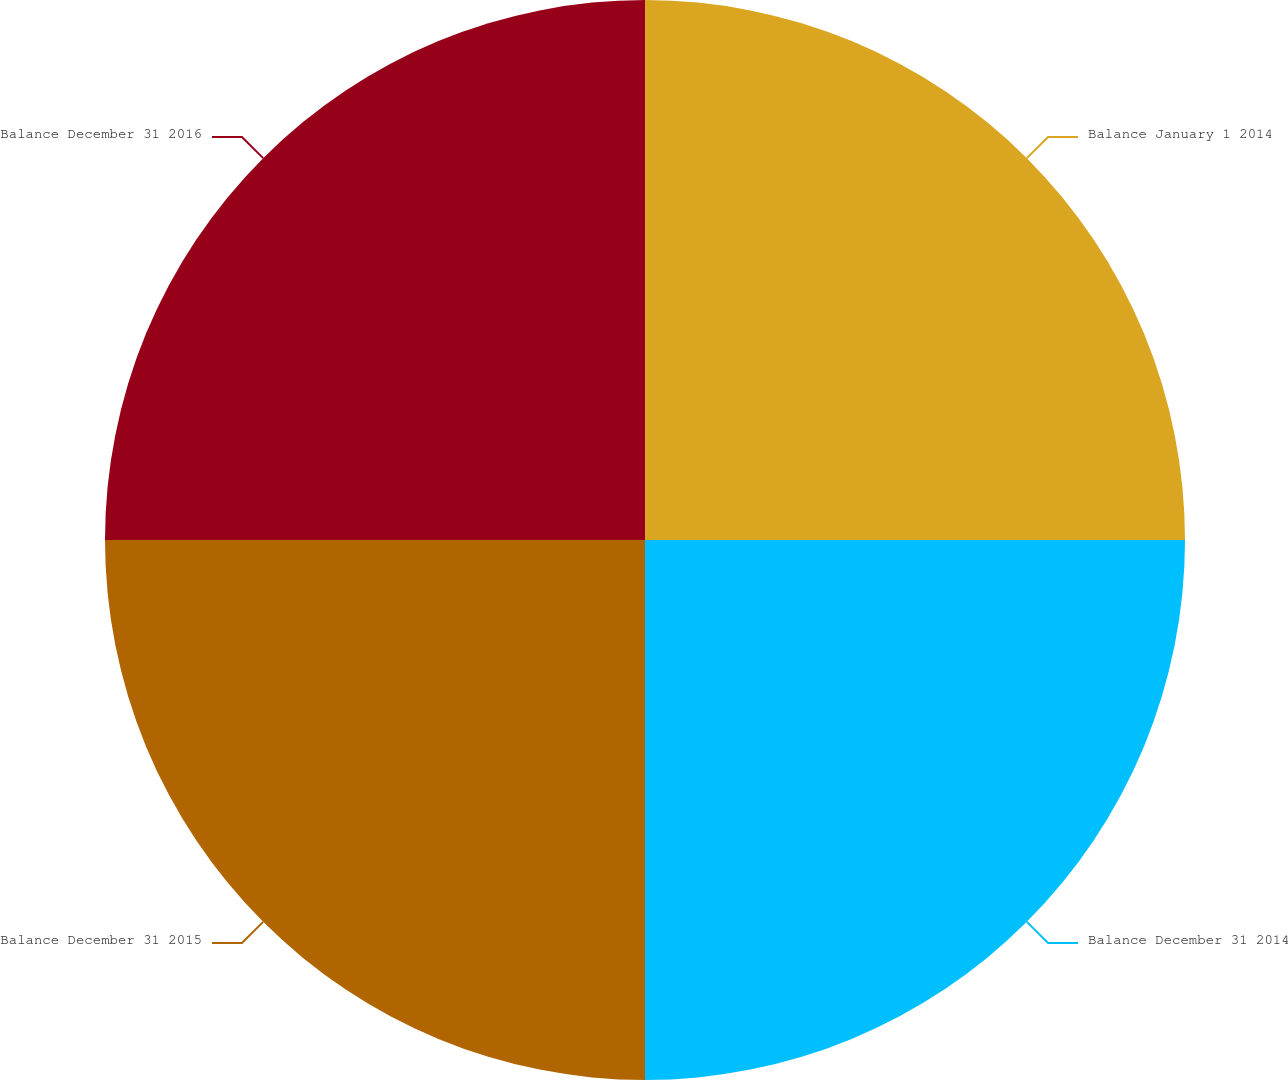<chart> <loc_0><loc_0><loc_500><loc_500><pie_chart><fcel>Balance January 1 2014<fcel>Balance December 31 2014<fcel>Balance December 31 2015<fcel>Balance December 31 2016<nl><fcel>25.0%<fcel>25.0%<fcel>25.0%<fcel>25.0%<nl></chart> 